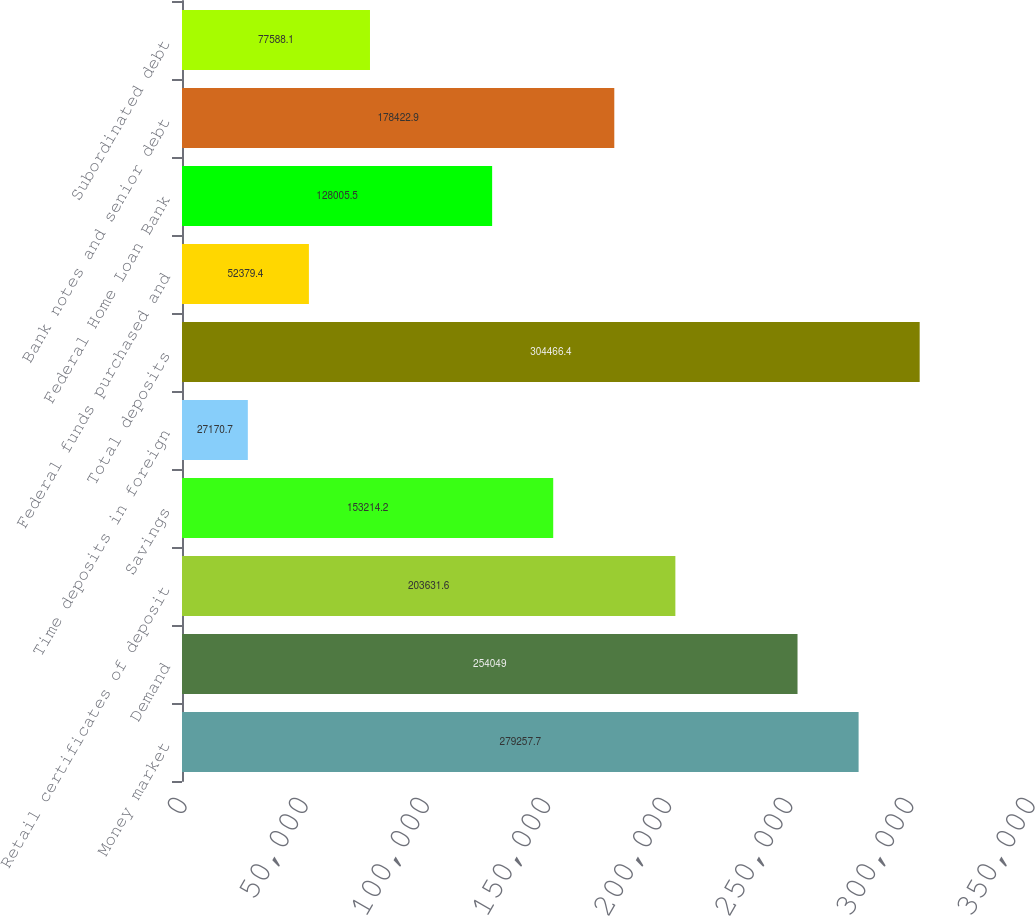<chart> <loc_0><loc_0><loc_500><loc_500><bar_chart><fcel>Money market<fcel>Demand<fcel>Retail certificates of deposit<fcel>Savings<fcel>Time deposits in foreign<fcel>Total deposits<fcel>Federal funds purchased and<fcel>Federal Home Loan Bank<fcel>Bank notes and senior debt<fcel>Subordinated debt<nl><fcel>279258<fcel>254049<fcel>203632<fcel>153214<fcel>27170.7<fcel>304466<fcel>52379.4<fcel>128006<fcel>178423<fcel>77588.1<nl></chart> 